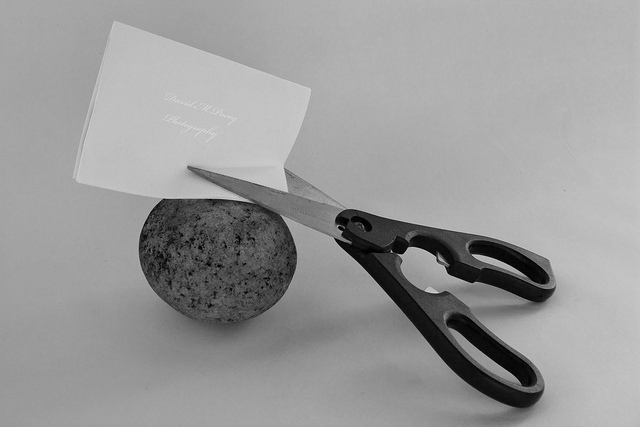<image>What square colorful image is above the scissors? It is ambiguous what square colorful image is above the scissors. There might not be one. What square colorful image is above the scissors? I don't know what square colorful image is above the scissors. It can be seen 'happy birthday card', 'white paper', 'letter', 'none', 'paper', 'card', or 'invite'. 